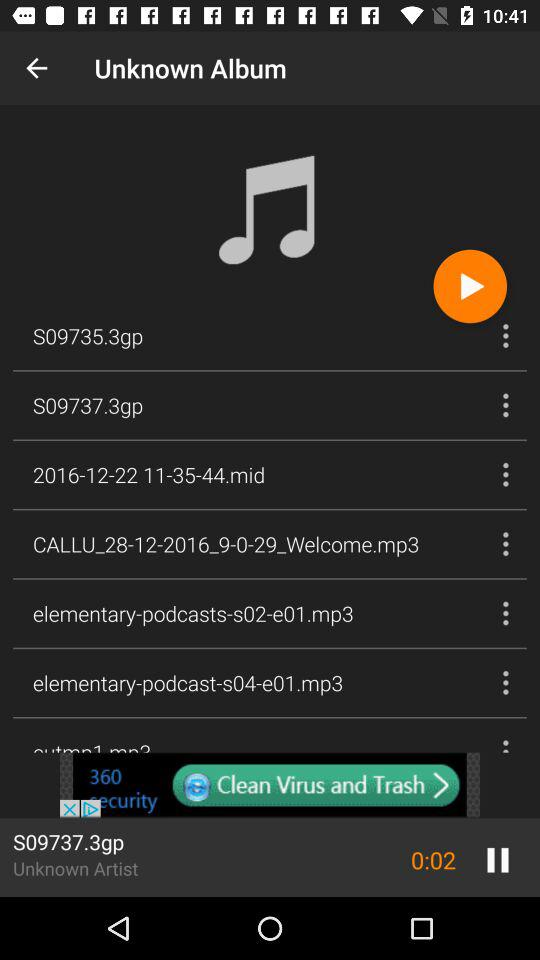How many songs are in the album?
When the provided information is insufficient, respond with <no answer>. <no answer> 